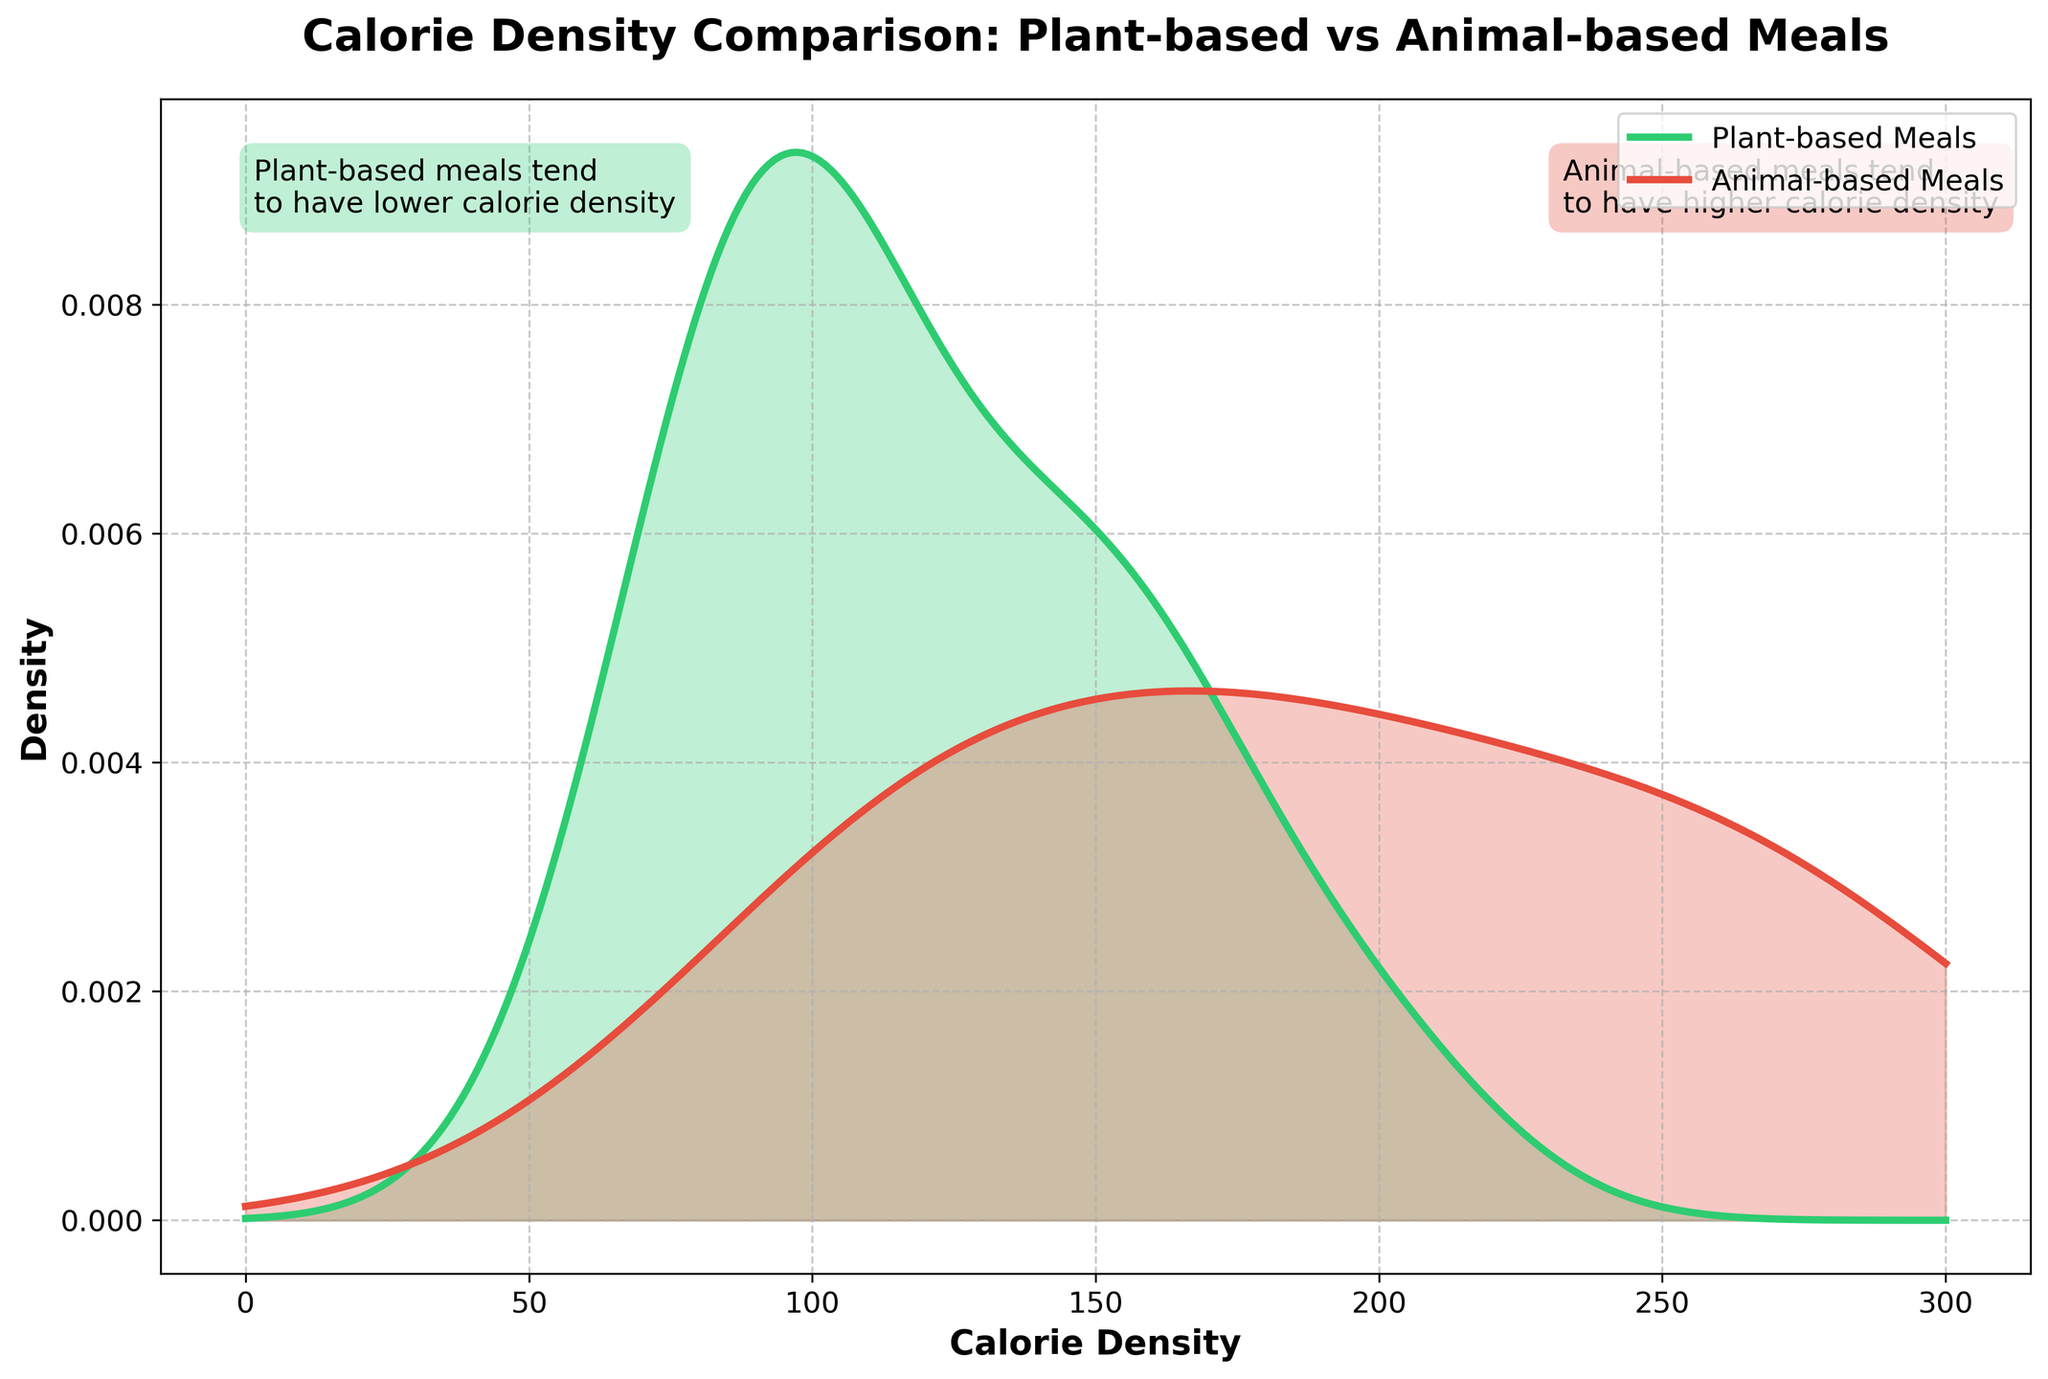What are the two groups being compared in the title? The title of the plot is "Calorie Density Comparison: Plant-based vs Animal-based Meals," indicating that the two groups being compared are Plant-based Meals and Animal-based Meals
Answer: Plant-based and Animal-based Meals Which color represents plant-based meals and which represents animal-based meals? Looking at the legend, the green color represents Plant-based Meals and the red color represents Animal-based Meals
Answer: Green for Plant-based, Red for Animal-based What is the highest peak density value for plant-based meals? The highest peak of the green line representing plant-based meals on the y-axis corresponds to a density value of approximately 0.025
Answer: Approximately 0.025 What is the overall trend in calorie density for plant-based meals as compared to animal-based meals? The green line for plant-based meals is predominantly to the left of the red line for animal-based meals, indicating that plant-based meals generally have a lower calorie density
Answer: Lower calorie density At which calorie density do plant-based meals peak, and how does this compare to the peak of animal-based meals? Plant-based meals peak around 100 calories per density, while animal-based meals appear to peak around 220 calories per density
Answer: 100 vs 220 What annotation is given for plant-based meals? The green box with text for plant-based meals says, "Plant-based meals tend to have lower calorie density"
Answer: Tend to have lower calorie density In what range do both plant-based and animal-based meals have overlapping density? Both green and red lines overlap in the density range between 90 and 180 calories per density
Answer: 90 to 180 How do the density curves for animal-based meals compare beyond 250 calorie-density? Beyond 250 calorie-density, the density curve for animal-based meals continues while the plant-based meals curve is essentially zero
Answer: Higher density beyond 250 What is the density at 150 calorie-density for both plant-based and animal-based meals? At 150 calorie-density, the density for plant-based meals is approximately 0.014, and for animal-based meals, it's approximately 0.011
Answer: 0.014 vs 0.011 